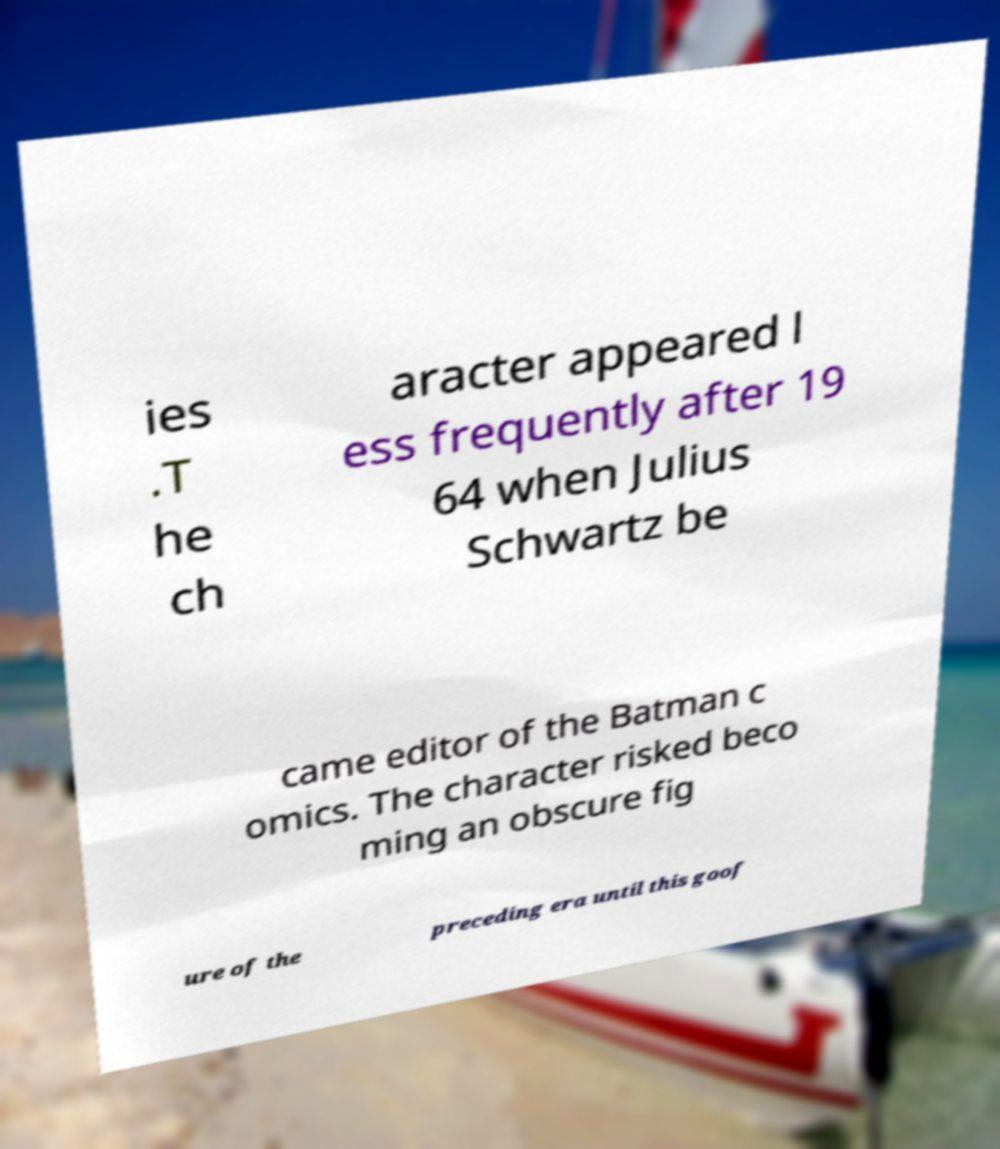Can you accurately transcribe the text from the provided image for me? ies .T he ch aracter appeared l ess frequently after 19 64 when Julius Schwartz be came editor of the Batman c omics. The character risked beco ming an obscure fig ure of the preceding era until this goof 